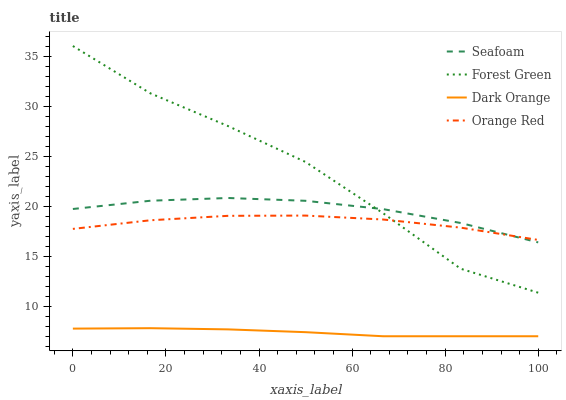Does Dark Orange have the minimum area under the curve?
Answer yes or no. Yes. Does Forest Green have the maximum area under the curve?
Answer yes or no. Yes. Does Seafoam have the minimum area under the curve?
Answer yes or no. No. Does Seafoam have the maximum area under the curve?
Answer yes or no. No. Is Dark Orange the smoothest?
Answer yes or no. Yes. Is Forest Green the roughest?
Answer yes or no. Yes. Is Seafoam the smoothest?
Answer yes or no. No. Is Seafoam the roughest?
Answer yes or no. No. Does Dark Orange have the lowest value?
Answer yes or no. Yes. Does Forest Green have the lowest value?
Answer yes or no. No. Does Forest Green have the highest value?
Answer yes or no. Yes. Does Seafoam have the highest value?
Answer yes or no. No. Is Dark Orange less than Forest Green?
Answer yes or no. Yes. Is Seafoam greater than Dark Orange?
Answer yes or no. Yes. Does Forest Green intersect Orange Red?
Answer yes or no. Yes. Is Forest Green less than Orange Red?
Answer yes or no. No. Is Forest Green greater than Orange Red?
Answer yes or no. No. Does Dark Orange intersect Forest Green?
Answer yes or no. No. 